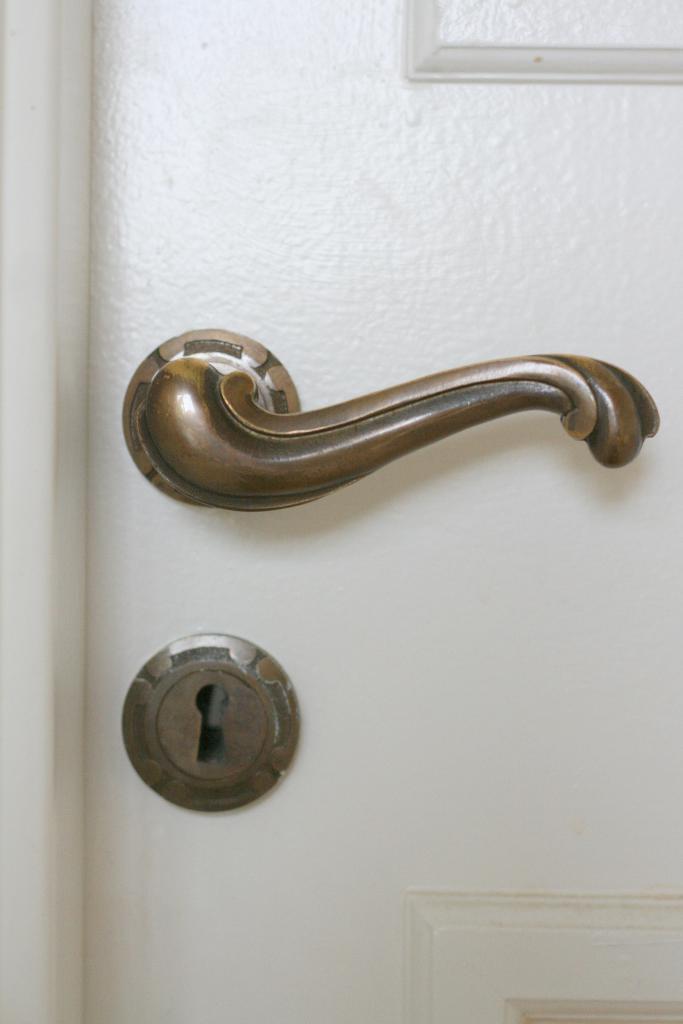Could you give a brief overview of what you see in this image? This image consists of a door. In the front, we can see a handle along with a lock. 